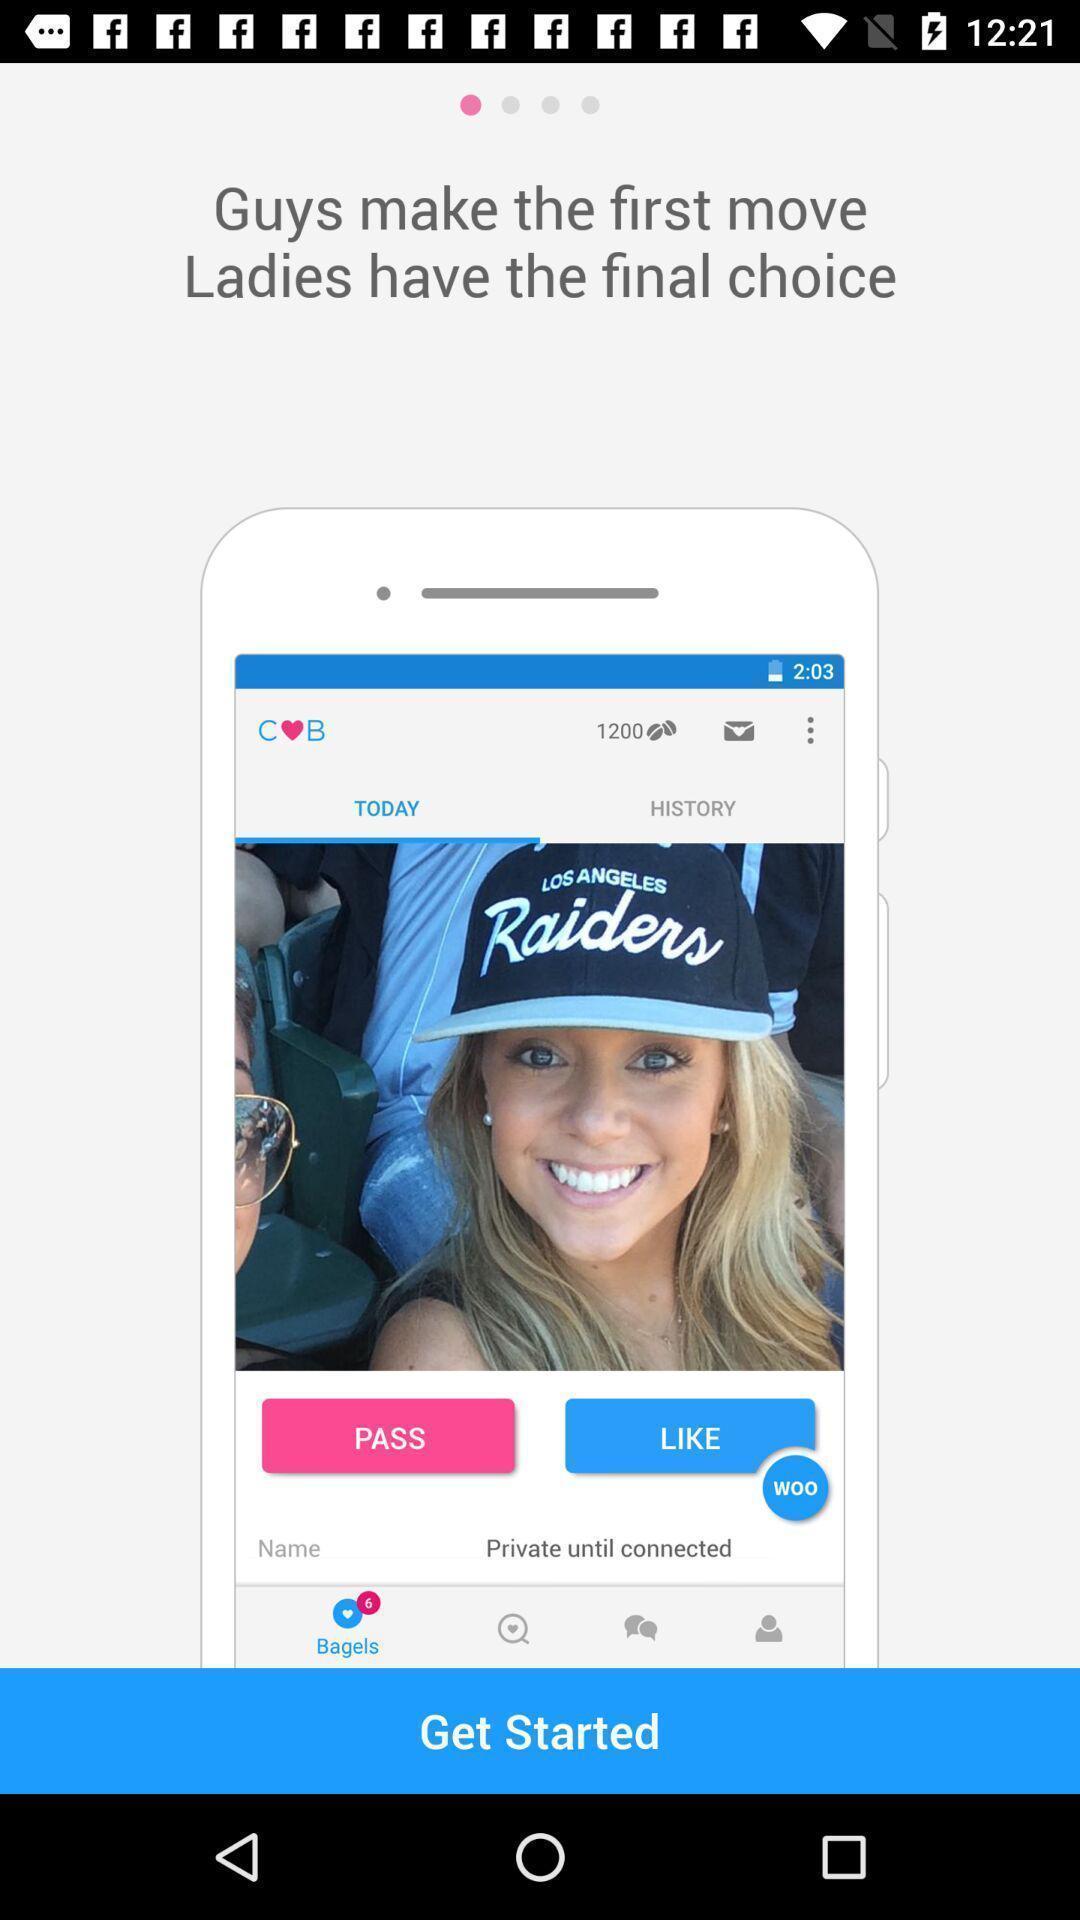What is the overall content of this screenshot? Starting page for a dating app. 